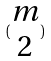Convert formula to latex. <formula><loc_0><loc_0><loc_500><loc_500>( \begin{matrix} m \\ 2 \end{matrix} )</formula> 